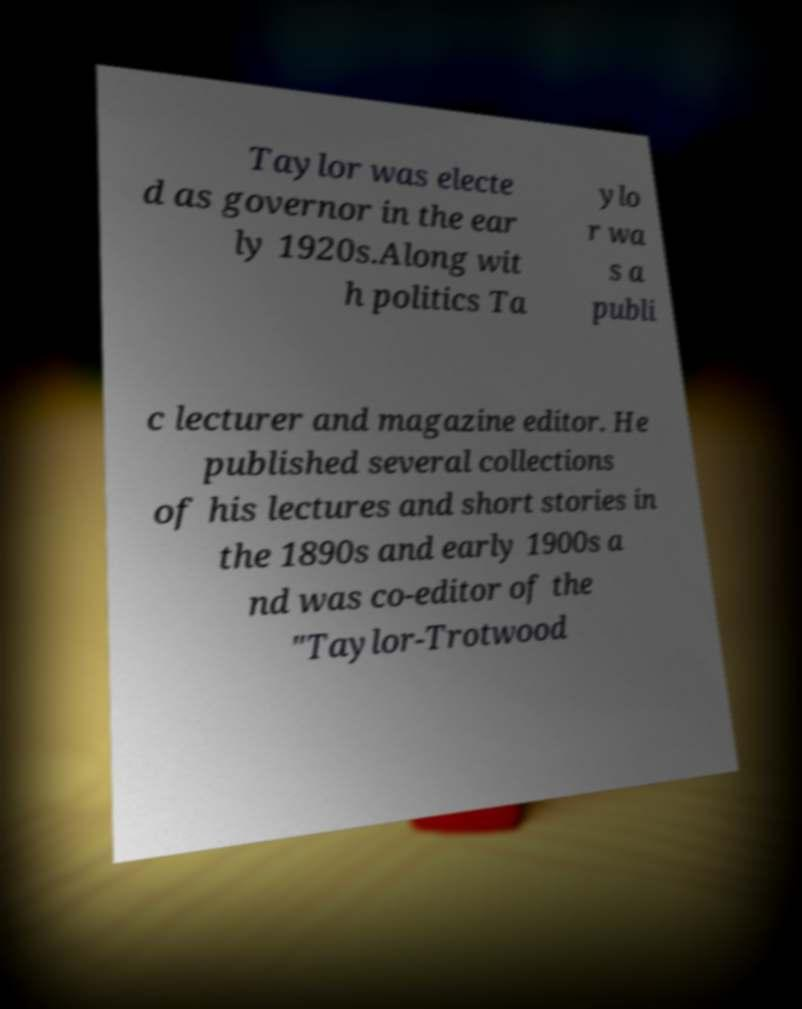Could you extract and type out the text from this image? Taylor was electe d as governor in the ear ly 1920s.Along wit h politics Ta ylo r wa s a publi c lecturer and magazine editor. He published several collections of his lectures and short stories in the 1890s and early 1900s a nd was co-editor of the "Taylor-Trotwood 